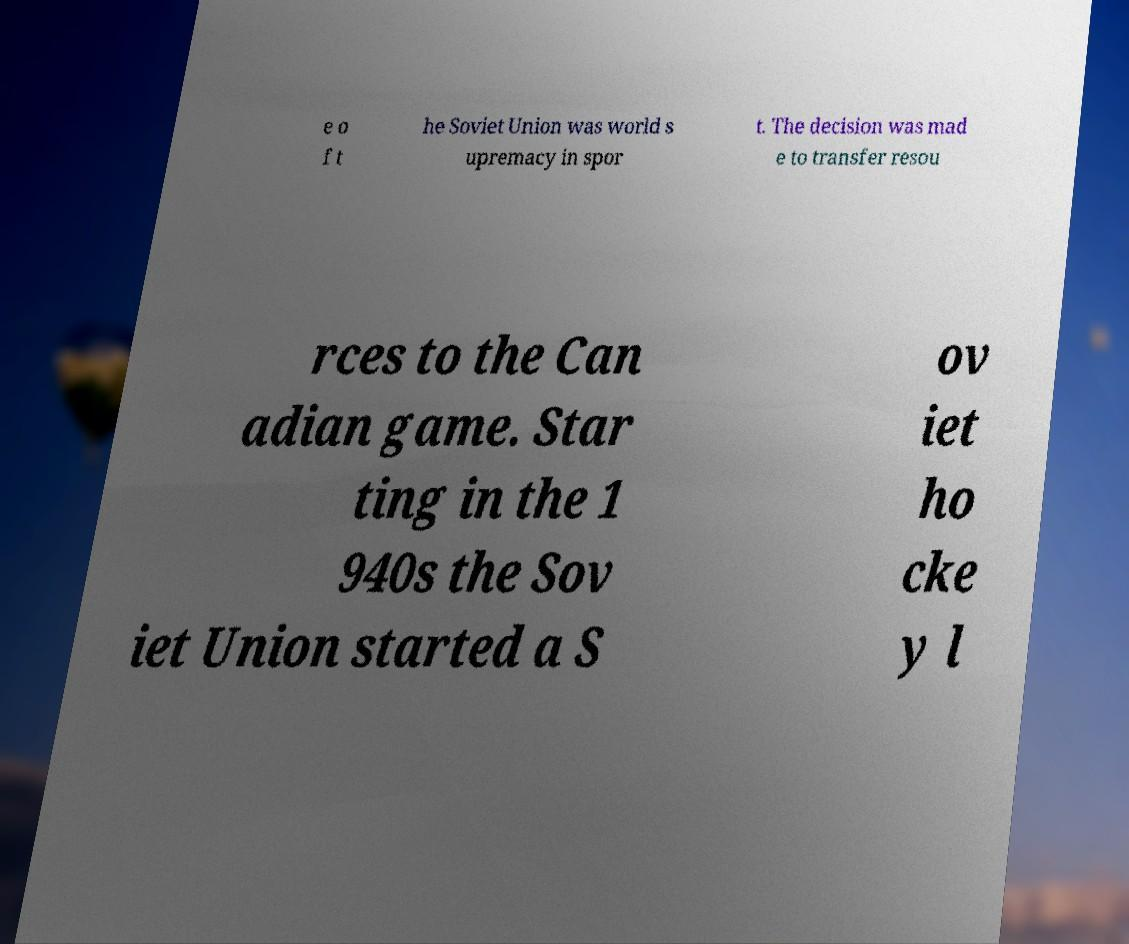Please identify and transcribe the text found in this image. e o f t he Soviet Union was world s upremacy in spor t. The decision was mad e to transfer resou rces to the Can adian game. Star ting in the 1 940s the Sov iet Union started a S ov iet ho cke y l 